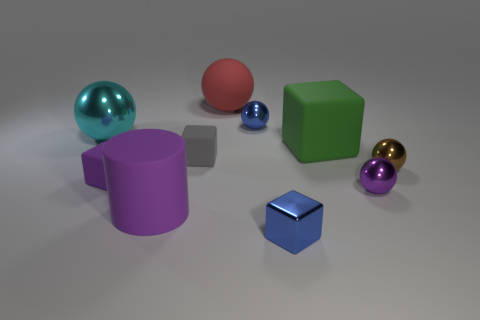What are the shapes and colors of the objects in the foreground? The foreground features a variety of geometric shapes: there is a small blue cube, a purplish-pink cylinder, and a reflective blue sphere. 